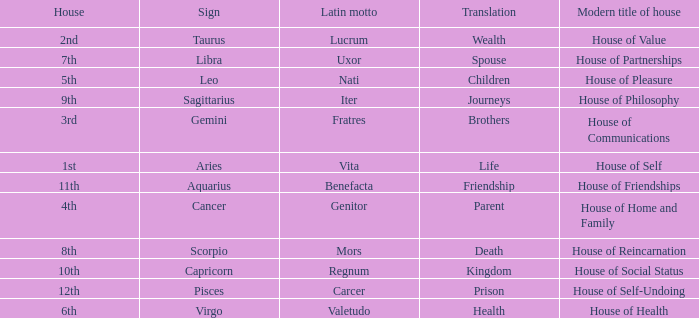What is the Latin motto of the sign that translates to spouse? Uxor. 